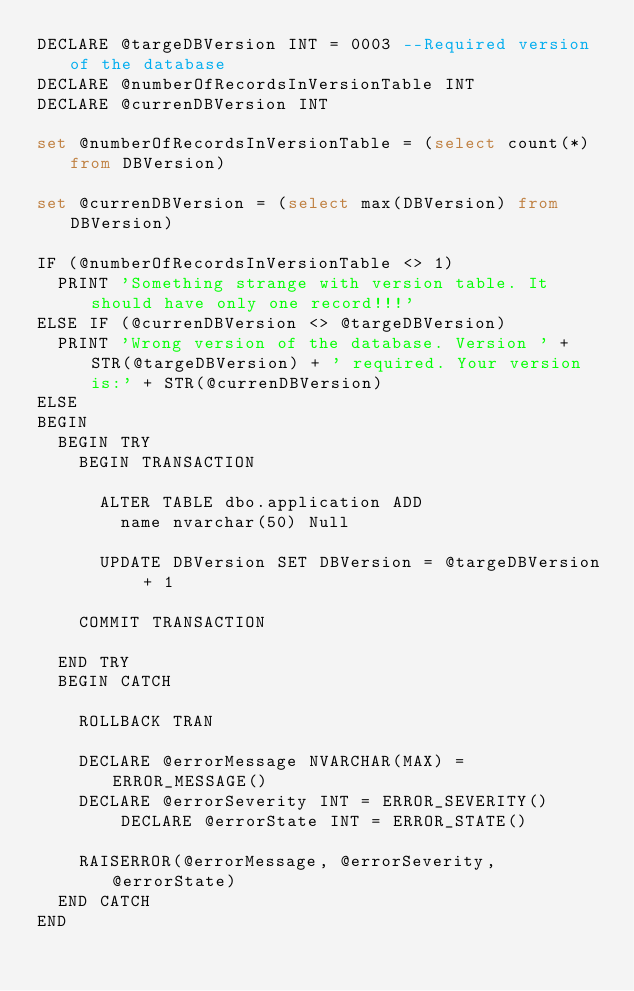Convert code to text. <code><loc_0><loc_0><loc_500><loc_500><_SQL_>DECLARE @targeDBVersion INT = 0003 --Required version of the database
DECLARE @numberOfRecordsInVersionTable INT
DECLARE @currenDBVersion INT

set @numberOfRecordsInVersionTable = (select count(*) from DBVersion)

set @currenDBVersion = (select max(DBVersion) from DBVersion)

IF (@numberOfRecordsInVersionTable <> 1)
	PRINT 'Something strange with version table. It should have only one record!!!'
ELSE IF (@currenDBVersion <> @targeDBVersion)
	PRINT 'Wrong version of the database. Version ' + STR(@targeDBVersion) + ' required. Your version is:' + STR(@currenDBVersion)
ELSE
BEGIN
	BEGIN TRY	
		BEGIN TRANSACTION
			
			ALTER TABLE dbo.application ADD
				name nvarchar(50) Null
						
			UPDATE DBVersion SET DBVersion = @targeDBVersion + 1
			
		COMMIT TRANSACTION                                                                          
		
	END TRY
	BEGIN CATCH
	
		ROLLBACK TRAN
		
		DECLARE @errorMessage NVARCHAR(MAX) = ERROR_MESSAGE()
		DECLARE @errorSeverity INT = ERROR_SEVERITY()
        DECLARE @errorState INT = ERROR_STATE()
        
		RAISERROR(@errorMessage, @errorSeverity, @errorState)
	END CATCH
END</code> 